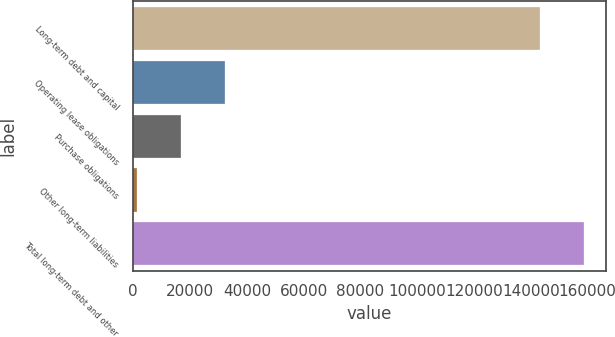Convert chart to OTSL. <chart><loc_0><loc_0><loc_500><loc_500><bar_chart><fcel>Long-term debt and capital<fcel>Operating lease obligations<fcel>Purchase obligations<fcel>Other long-term liabilities<fcel>Total long-term debt and other<nl><fcel>143220<fcel>32160.4<fcel>16812.2<fcel>1464<fcel>158568<nl></chart> 